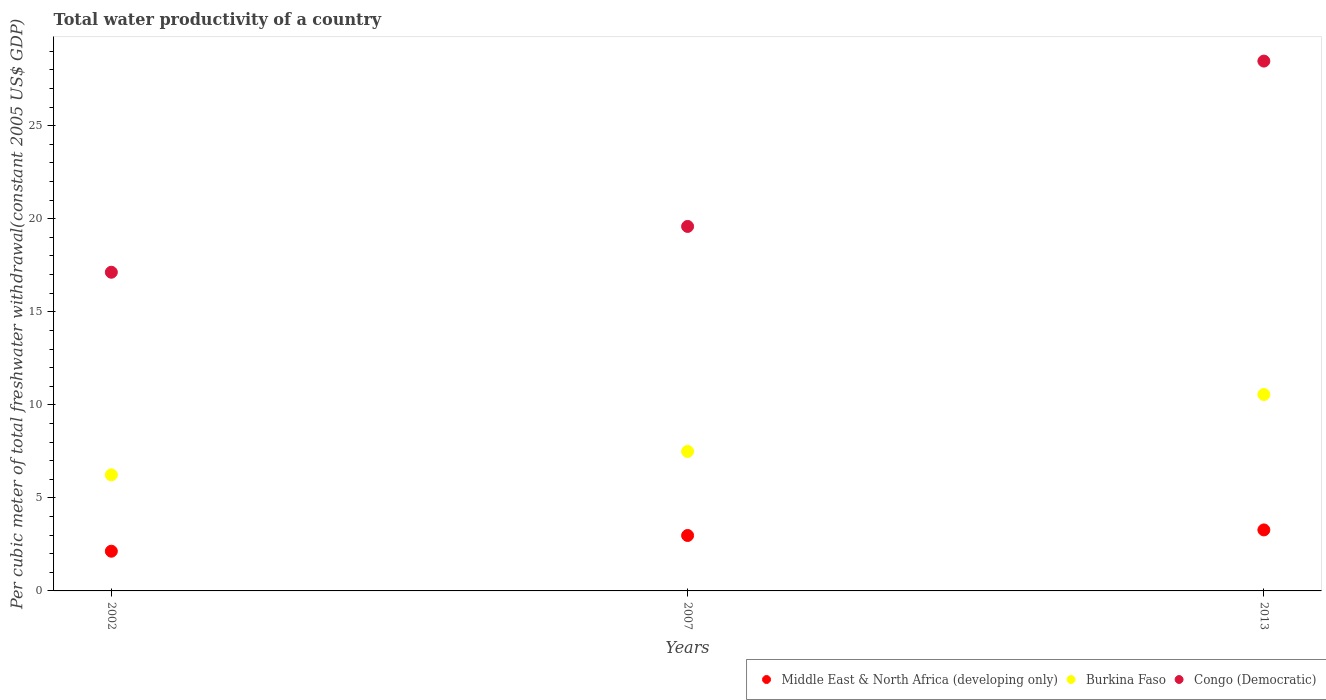What is the total water productivity in Burkina Faso in 2002?
Offer a terse response. 6.24. Across all years, what is the maximum total water productivity in Congo (Democratic)?
Ensure brevity in your answer.  28.47. Across all years, what is the minimum total water productivity in Congo (Democratic)?
Ensure brevity in your answer.  17.13. What is the total total water productivity in Burkina Faso in the graph?
Your response must be concise. 24.29. What is the difference between the total water productivity in Congo (Democratic) in 2007 and that in 2013?
Your answer should be very brief. -8.89. What is the difference between the total water productivity in Congo (Democratic) in 2002 and the total water productivity in Burkina Faso in 2007?
Your response must be concise. 9.63. What is the average total water productivity in Congo (Democratic) per year?
Make the answer very short. 21.73. In the year 2007, what is the difference between the total water productivity in Burkina Faso and total water productivity in Middle East & North Africa (developing only)?
Provide a short and direct response. 4.52. What is the ratio of the total water productivity in Burkina Faso in 2007 to that in 2013?
Give a very brief answer. 0.71. What is the difference between the highest and the second highest total water productivity in Burkina Faso?
Offer a terse response. 3.06. What is the difference between the highest and the lowest total water productivity in Middle East & North Africa (developing only)?
Offer a terse response. 1.14. Is the sum of the total water productivity in Congo (Democratic) in 2007 and 2013 greater than the maximum total water productivity in Burkina Faso across all years?
Provide a succinct answer. Yes. Is it the case that in every year, the sum of the total water productivity in Congo (Democratic) and total water productivity in Burkina Faso  is greater than the total water productivity in Middle East & North Africa (developing only)?
Your response must be concise. Yes. Is the total water productivity in Middle East & North Africa (developing only) strictly greater than the total water productivity in Congo (Democratic) over the years?
Your response must be concise. No. How many dotlines are there?
Provide a succinct answer. 3. How many years are there in the graph?
Keep it short and to the point. 3. What is the difference between two consecutive major ticks on the Y-axis?
Offer a terse response. 5. Does the graph contain grids?
Make the answer very short. No. Where does the legend appear in the graph?
Your answer should be compact. Bottom right. How many legend labels are there?
Offer a very short reply. 3. How are the legend labels stacked?
Your answer should be compact. Horizontal. What is the title of the graph?
Make the answer very short. Total water productivity of a country. Does "Gambia, The" appear as one of the legend labels in the graph?
Provide a succinct answer. No. What is the label or title of the X-axis?
Make the answer very short. Years. What is the label or title of the Y-axis?
Offer a terse response. Per cubic meter of total freshwater withdrawal(constant 2005 US$ GDP). What is the Per cubic meter of total freshwater withdrawal(constant 2005 US$ GDP) of Middle East & North Africa (developing only) in 2002?
Give a very brief answer. 2.13. What is the Per cubic meter of total freshwater withdrawal(constant 2005 US$ GDP) of Burkina Faso in 2002?
Your answer should be very brief. 6.24. What is the Per cubic meter of total freshwater withdrawal(constant 2005 US$ GDP) in Congo (Democratic) in 2002?
Offer a very short reply. 17.13. What is the Per cubic meter of total freshwater withdrawal(constant 2005 US$ GDP) in Middle East & North Africa (developing only) in 2007?
Your response must be concise. 2.98. What is the Per cubic meter of total freshwater withdrawal(constant 2005 US$ GDP) in Burkina Faso in 2007?
Ensure brevity in your answer.  7.5. What is the Per cubic meter of total freshwater withdrawal(constant 2005 US$ GDP) in Congo (Democratic) in 2007?
Your answer should be compact. 19.59. What is the Per cubic meter of total freshwater withdrawal(constant 2005 US$ GDP) in Middle East & North Africa (developing only) in 2013?
Your answer should be very brief. 3.28. What is the Per cubic meter of total freshwater withdrawal(constant 2005 US$ GDP) in Burkina Faso in 2013?
Ensure brevity in your answer.  10.56. What is the Per cubic meter of total freshwater withdrawal(constant 2005 US$ GDP) in Congo (Democratic) in 2013?
Provide a succinct answer. 28.47. Across all years, what is the maximum Per cubic meter of total freshwater withdrawal(constant 2005 US$ GDP) in Middle East & North Africa (developing only)?
Your answer should be very brief. 3.28. Across all years, what is the maximum Per cubic meter of total freshwater withdrawal(constant 2005 US$ GDP) in Burkina Faso?
Your answer should be compact. 10.56. Across all years, what is the maximum Per cubic meter of total freshwater withdrawal(constant 2005 US$ GDP) in Congo (Democratic)?
Give a very brief answer. 28.47. Across all years, what is the minimum Per cubic meter of total freshwater withdrawal(constant 2005 US$ GDP) in Middle East & North Africa (developing only)?
Give a very brief answer. 2.13. Across all years, what is the minimum Per cubic meter of total freshwater withdrawal(constant 2005 US$ GDP) of Burkina Faso?
Offer a terse response. 6.24. Across all years, what is the minimum Per cubic meter of total freshwater withdrawal(constant 2005 US$ GDP) in Congo (Democratic)?
Give a very brief answer. 17.13. What is the total Per cubic meter of total freshwater withdrawal(constant 2005 US$ GDP) in Middle East & North Africa (developing only) in the graph?
Your answer should be very brief. 8.39. What is the total Per cubic meter of total freshwater withdrawal(constant 2005 US$ GDP) in Burkina Faso in the graph?
Your answer should be very brief. 24.29. What is the total Per cubic meter of total freshwater withdrawal(constant 2005 US$ GDP) in Congo (Democratic) in the graph?
Keep it short and to the point. 65.19. What is the difference between the Per cubic meter of total freshwater withdrawal(constant 2005 US$ GDP) of Middle East & North Africa (developing only) in 2002 and that in 2007?
Keep it short and to the point. -0.84. What is the difference between the Per cubic meter of total freshwater withdrawal(constant 2005 US$ GDP) in Burkina Faso in 2002 and that in 2007?
Provide a succinct answer. -1.26. What is the difference between the Per cubic meter of total freshwater withdrawal(constant 2005 US$ GDP) of Congo (Democratic) in 2002 and that in 2007?
Ensure brevity in your answer.  -2.46. What is the difference between the Per cubic meter of total freshwater withdrawal(constant 2005 US$ GDP) in Middle East & North Africa (developing only) in 2002 and that in 2013?
Provide a short and direct response. -1.14. What is the difference between the Per cubic meter of total freshwater withdrawal(constant 2005 US$ GDP) in Burkina Faso in 2002 and that in 2013?
Your response must be concise. -4.32. What is the difference between the Per cubic meter of total freshwater withdrawal(constant 2005 US$ GDP) in Congo (Democratic) in 2002 and that in 2013?
Keep it short and to the point. -11.35. What is the difference between the Per cubic meter of total freshwater withdrawal(constant 2005 US$ GDP) in Middle East & North Africa (developing only) in 2007 and that in 2013?
Give a very brief answer. -0.3. What is the difference between the Per cubic meter of total freshwater withdrawal(constant 2005 US$ GDP) in Burkina Faso in 2007 and that in 2013?
Give a very brief answer. -3.06. What is the difference between the Per cubic meter of total freshwater withdrawal(constant 2005 US$ GDP) of Congo (Democratic) in 2007 and that in 2013?
Give a very brief answer. -8.89. What is the difference between the Per cubic meter of total freshwater withdrawal(constant 2005 US$ GDP) in Middle East & North Africa (developing only) in 2002 and the Per cubic meter of total freshwater withdrawal(constant 2005 US$ GDP) in Burkina Faso in 2007?
Provide a short and direct response. -5.36. What is the difference between the Per cubic meter of total freshwater withdrawal(constant 2005 US$ GDP) in Middle East & North Africa (developing only) in 2002 and the Per cubic meter of total freshwater withdrawal(constant 2005 US$ GDP) in Congo (Democratic) in 2007?
Offer a terse response. -17.45. What is the difference between the Per cubic meter of total freshwater withdrawal(constant 2005 US$ GDP) in Burkina Faso in 2002 and the Per cubic meter of total freshwater withdrawal(constant 2005 US$ GDP) in Congo (Democratic) in 2007?
Your answer should be very brief. -13.35. What is the difference between the Per cubic meter of total freshwater withdrawal(constant 2005 US$ GDP) of Middle East & North Africa (developing only) in 2002 and the Per cubic meter of total freshwater withdrawal(constant 2005 US$ GDP) of Burkina Faso in 2013?
Your answer should be compact. -8.42. What is the difference between the Per cubic meter of total freshwater withdrawal(constant 2005 US$ GDP) of Middle East & North Africa (developing only) in 2002 and the Per cubic meter of total freshwater withdrawal(constant 2005 US$ GDP) of Congo (Democratic) in 2013?
Make the answer very short. -26.34. What is the difference between the Per cubic meter of total freshwater withdrawal(constant 2005 US$ GDP) in Burkina Faso in 2002 and the Per cubic meter of total freshwater withdrawal(constant 2005 US$ GDP) in Congo (Democratic) in 2013?
Ensure brevity in your answer.  -22.24. What is the difference between the Per cubic meter of total freshwater withdrawal(constant 2005 US$ GDP) of Middle East & North Africa (developing only) in 2007 and the Per cubic meter of total freshwater withdrawal(constant 2005 US$ GDP) of Burkina Faso in 2013?
Your answer should be very brief. -7.58. What is the difference between the Per cubic meter of total freshwater withdrawal(constant 2005 US$ GDP) of Middle East & North Africa (developing only) in 2007 and the Per cubic meter of total freshwater withdrawal(constant 2005 US$ GDP) of Congo (Democratic) in 2013?
Offer a very short reply. -25.49. What is the difference between the Per cubic meter of total freshwater withdrawal(constant 2005 US$ GDP) in Burkina Faso in 2007 and the Per cubic meter of total freshwater withdrawal(constant 2005 US$ GDP) in Congo (Democratic) in 2013?
Offer a very short reply. -20.98. What is the average Per cubic meter of total freshwater withdrawal(constant 2005 US$ GDP) of Middle East & North Africa (developing only) per year?
Keep it short and to the point. 2.8. What is the average Per cubic meter of total freshwater withdrawal(constant 2005 US$ GDP) in Burkina Faso per year?
Give a very brief answer. 8.1. What is the average Per cubic meter of total freshwater withdrawal(constant 2005 US$ GDP) in Congo (Democratic) per year?
Offer a very short reply. 21.73. In the year 2002, what is the difference between the Per cubic meter of total freshwater withdrawal(constant 2005 US$ GDP) in Middle East & North Africa (developing only) and Per cubic meter of total freshwater withdrawal(constant 2005 US$ GDP) in Burkina Faso?
Give a very brief answer. -4.1. In the year 2002, what is the difference between the Per cubic meter of total freshwater withdrawal(constant 2005 US$ GDP) of Middle East & North Africa (developing only) and Per cubic meter of total freshwater withdrawal(constant 2005 US$ GDP) of Congo (Democratic)?
Give a very brief answer. -14.99. In the year 2002, what is the difference between the Per cubic meter of total freshwater withdrawal(constant 2005 US$ GDP) in Burkina Faso and Per cubic meter of total freshwater withdrawal(constant 2005 US$ GDP) in Congo (Democratic)?
Ensure brevity in your answer.  -10.89. In the year 2007, what is the difference between the Per cubic meter of total freshwater withdrawal(constant 2005 US$ GDP) in Middle East & North Africa (developing only) and Per cubic meter of total freshwater withdrawal(constant 2005 US$ GDP) in Burkina Faso?
Your response must be concise. -4.52. In the year 2007, what is the difference between the Per cubic meter of total freshwater withdrawal(constant 2005 US$ GDP) in Middle East & North Africa (developing only) and Per cubic meter of total freshwater withdrawal(constant 2005 US$ GDP) in Congo (Democratic)?
Provide a short and direct response. -16.61. In the year 2007, what is the difference between the Per cubic meter of total freshwater withdrawal(constant 2005 US$ GDP) in Burkina Faso and Per cubic meter of total freshwater withdrawal(constant 2005 US$ GDP) in Congo (Democratic)?
Provide a succinct answer. -12.09. In the year 2013, what is the difference between the Per cubic meter of total freshwater withdrawal(constant 2005 US$ GDP) of Middle East & North Africa (developing only) and Per cubic meter of total freshwater withdrawal(constant 2005 US$ GDP) of Burkina Faso?
Your answer should be very brief. -7.28. In the year 2013, what is the difference between the Per cubic meter of total freshwater withdrawal(constant 2005 US$ GDP) of Middle East & North Africa (developing only) and Per cubic meter of total freshwater withdrawal(constant 2005 US$ GDP) of Congo (Democratic)?
Offer a very short reply. -25.2. In the year 2013, what is the difference between the Per cubic meter of total freshwater withdrawal(constant 2005 US$ GDP) of Burkina Faso and Per cubic meter of total freshwater withdrawal(constant 2005 US$ GDP) of Congo (Democratic)?
Offer a very short reply. -17.92. What is the ratio of the Per cubic meter of total freshwater withdrawal(constant 2005 US$ GDP) in Middle East & North Africa (developing only) in 2002 to that in 2007?
Your response must be concise. 0.72. What is the ratio of the Per cubic meter of total freshwater withdrawal(constant 2005 US$ GDP) in Burkina Faso in 2002 to that in 2007?
Ensure brevity in your answer.  0.83. What is the ratio of the Per cubic meter of total freshwater withdrawal(constant 2005 US$ GDP) of Congo (Democratic) in 2002 to that in 2007?
Your answer should be compact. 0.87. What is the ratio of the Per cubic meter of total freshwater withdrawal(constant 2005 US$ GDP) of Middle East & North Africa (developing only) in 2002 to that in 2013?
Your answer should be very brief. 0.65. What is the ratio of the Per cubic meter of total freshwater withdrawal(constant 2005 US$ GDP) in Burkina Faso in 2002 to that in 2013?
Your response must be concise. 0.59. What is the ratio of the Per cubic meter of total freshwater withdrawal(constant 2005 US$ GDP) of Congo (Democratic) in 2002 to that in 2013?
Your answer should be compact. 0.6. What is the ratio of the Per cubic meter of total freshwater withdrawal(constant 2005 US$ GDP) in Middle East & North Africa (developing only) in 2007 to that in 2013?
Make the answer very short. 0.91. What is the ratio of the Per cubic meter of total freshwater withdrawal(constant 2005 US$ GDP) of Burkina Faso in 2007 to that in 2013?
Offer a very short reply. 0.71. What is the ratio of the Per cubic meter of total freshwater withdrawal(constant 2005 US$ GDP) of Congo (Democratic) in 2007 to that in 2013?
Your answer should be very brief. 0.69. What is the difference between the highest and the second highest Per cubic meter of total freshwater withdrawal(constant 2005 US$ GDP) of Middle East & North Africa (developing only)?
Provide a succinct answer. 0.3. What is the difference between the highest and the second highest Per cubic meter of total freshwater withdrawal(constant 2005 US$ GDP) in Burkina Faso?
Offer a very short reply. 3.06. What is the difference between the highest and the second highest Per cubic meter of total freshwater withdrawal(constant 2005 US$ GDP) of Congo (Democratic)?
Make the answer very short. 8.89. What is the difference between the highest and the lowest Per cubic meter of total freshwater withdrawal(constant 2005 US$ GDP) of Middle East & North Africa (developing only)?
Give a very brief answer. 1.14. What is the difference between the highest and the lowest Per cubic meter of total freshwater withdrawal(constant 2005 US$ GDP) of Burkina Faso?
Your answer should be compact. 4.32. What is the difference between the highest and the lowest Per cubic meter of total freshwater withdrawal(constant 2005 US$ GDP) of Congo (Democratic)?
Give a very brief answer. 11.35. 